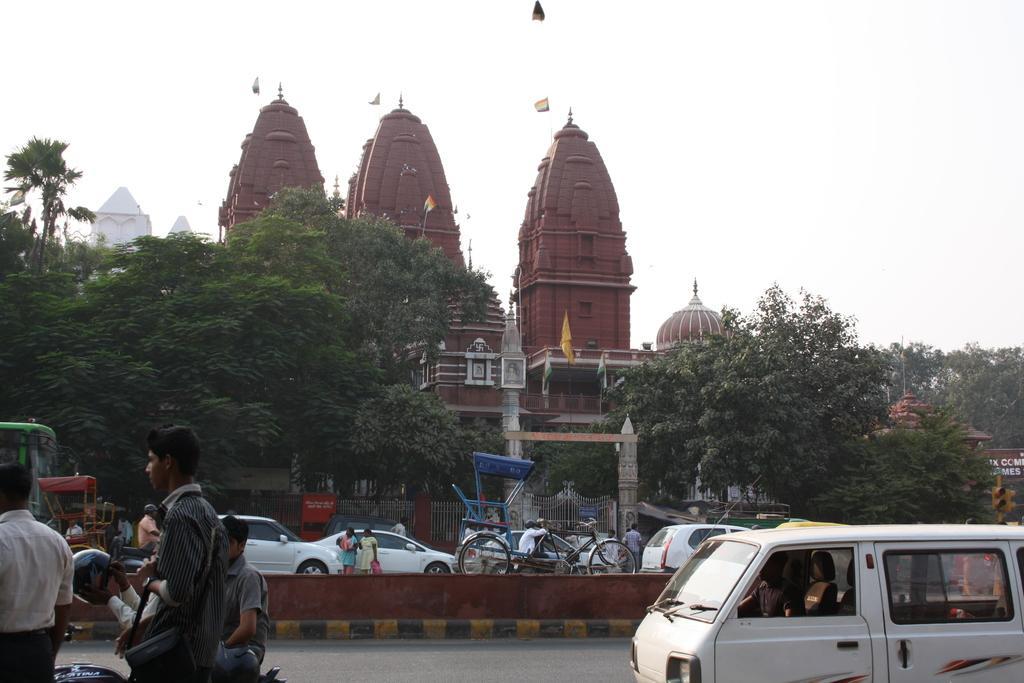Describe this image in one or two sentences. On a road there are few vehicles riding and few people are walking, Behind that there are trees and building and flag on top of the building. 